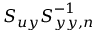<formula> <loc_0><loc_0><loc_500><loc_500>S _ { u y } S _ { y y , n } ^ { - 1 }</formula> 